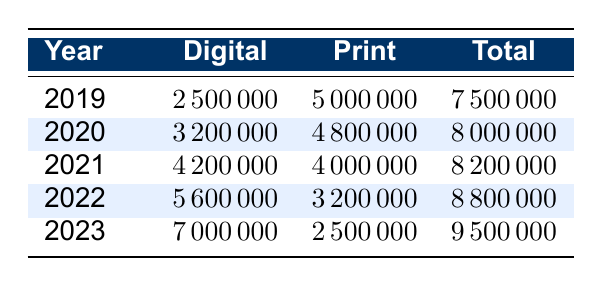What was the total number of subscriptions in 2021? In the row for the year 2021, the total subscriptions column shows 8200000.
Answer: 8200000 What is the change in digital subscriptions from 2019 to 2023? For 2019, digital subscriptions were 2500000 and for 2023, they are 7000000. The change is 7000000 - 2500000 = 4500000.
Answer: 4500000 Did print subscriptions decline from 2020 to 2023? The print subscriptions in 2020 were 4800000 and in 2023 they are 2500000. Since 2500000 is less than 4800000, print subscriptions did decline.
Answer: Yes What was the average number of total subscriptions over the five years? To find the average, sum the total subscriptions for each year: 7500000 + 8000000 + 8200000 + 8800000 + 9500000 = 41500000; then divide by 5: 41500000 / 5 = 8300000.
Answer: 8300000 In which year did digital subscriptions exceed half of total subscriptions for the first time? We can examine each year. In 2019, digital subscriptions were 33.33% of total. In 2020, they were 40%. In 2021, they rose to 51.22%. Thus, they exceeded half for the first time in 2021.
Answer: 2021 What was the total number of print subscriptions in 2022? According to the row for 2022, the print subscriptions column shows 3200000.
Answer: 3200000 How many more digital subscriptions were there in 2023 compared to 2021? Digital subscriptions in 2023 were 7000000 and in 2021 they were 4200000. The difference is 7000000 - 4200000 = 2800000.
Answer: 2800000 Is it true that digital subscriptions have increased every year from 2019 to 2023? By observing the digital subscription numbers yearly—2500000, 3200000, 4200000, 5600000, and 7000000—it is evident that they have increased each year.
Answer: Yes Which year had the highest number of print subscriptions? A look at the print subscriptions for each year shows that 2019 had the highest with 5000000 subscriptions.
Answer: 2019 